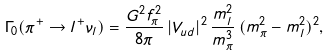<formula> <loc_0><loc_0><loc_500><loc_500>\Gamma _ { 0 } ( \pi ^ { + } \rightarrow l ^ { + } \nu _ { l } ) = \frac { G ^ { 2 } f ^ { 2 } _ { \pi } } { 8 \pi } \, | V _ { u d } | ^ { 2 } \, \frac { m ^ { 2 } _ { l } } { m ^ { 3 } _ { \pi } } \, ( m ^ { 2 } _ { \pi } - m ^ { 2 } _ { l } ) ^ { 2 } ,</formula> 